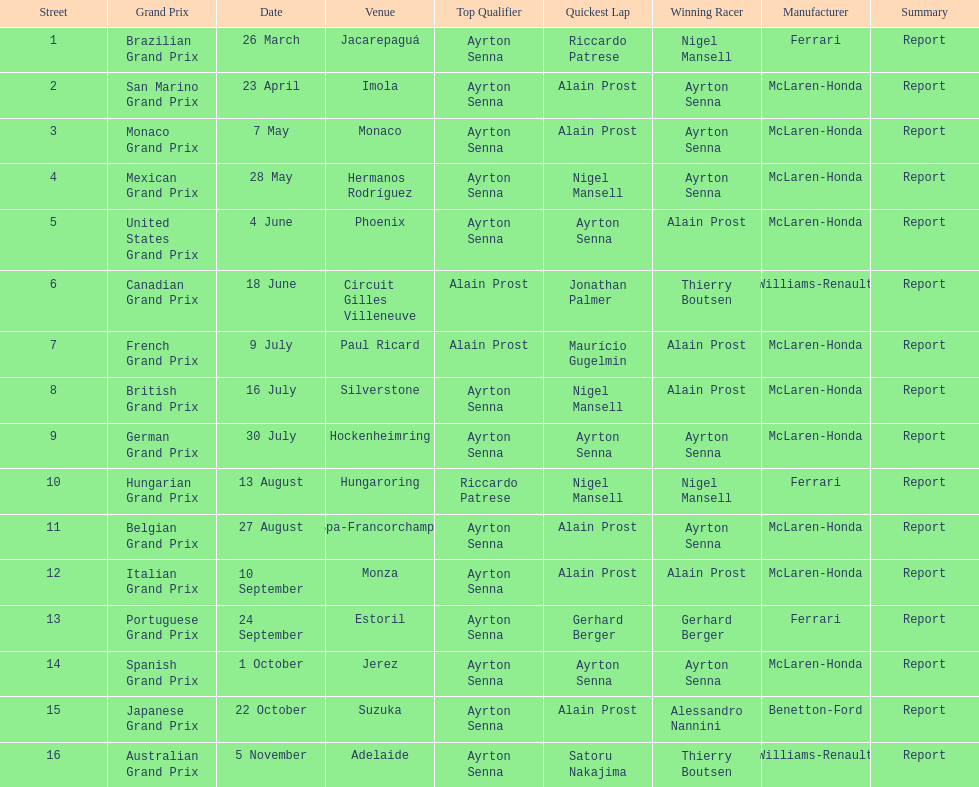What was the only grand prix to be won by benneton-ford? Japanese Grand Prix. 